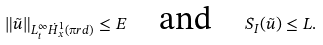Convert formula to latex. <formula><loc_0><loc_0><loc_500><loc_500>\| \tilde { u } \| _ { L _ { t } ^ { \infty } \dot { H } ^ { 1 } _ { x } ( \i r d ) } \leq E \quad \text {and} \quad S _ { I } ( \tilde { u } ) \leq L .</formula> 